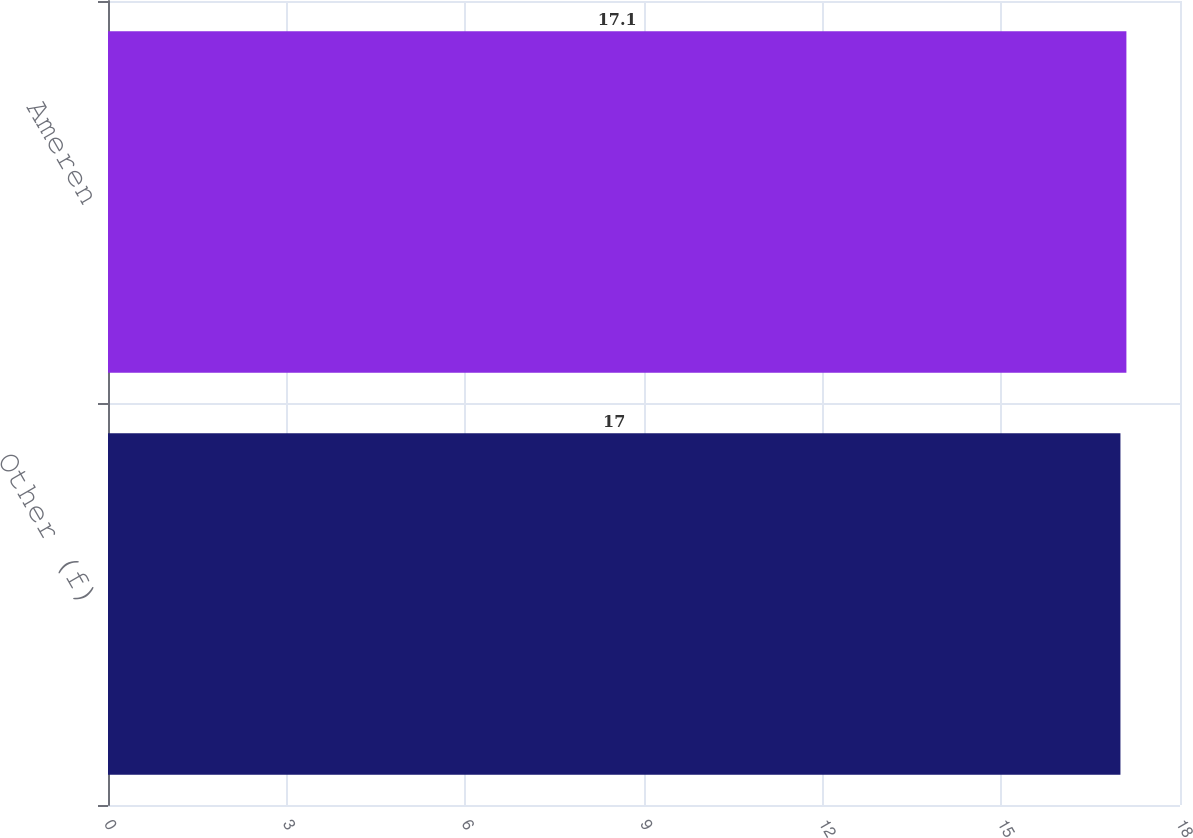<chart> <loc_0><loc_0><loc_500><loc_500><bar_chart><fcel>Other (f)<fcel>Ameren<nl><fcel>17<fcel>17.1<nl></chart> 